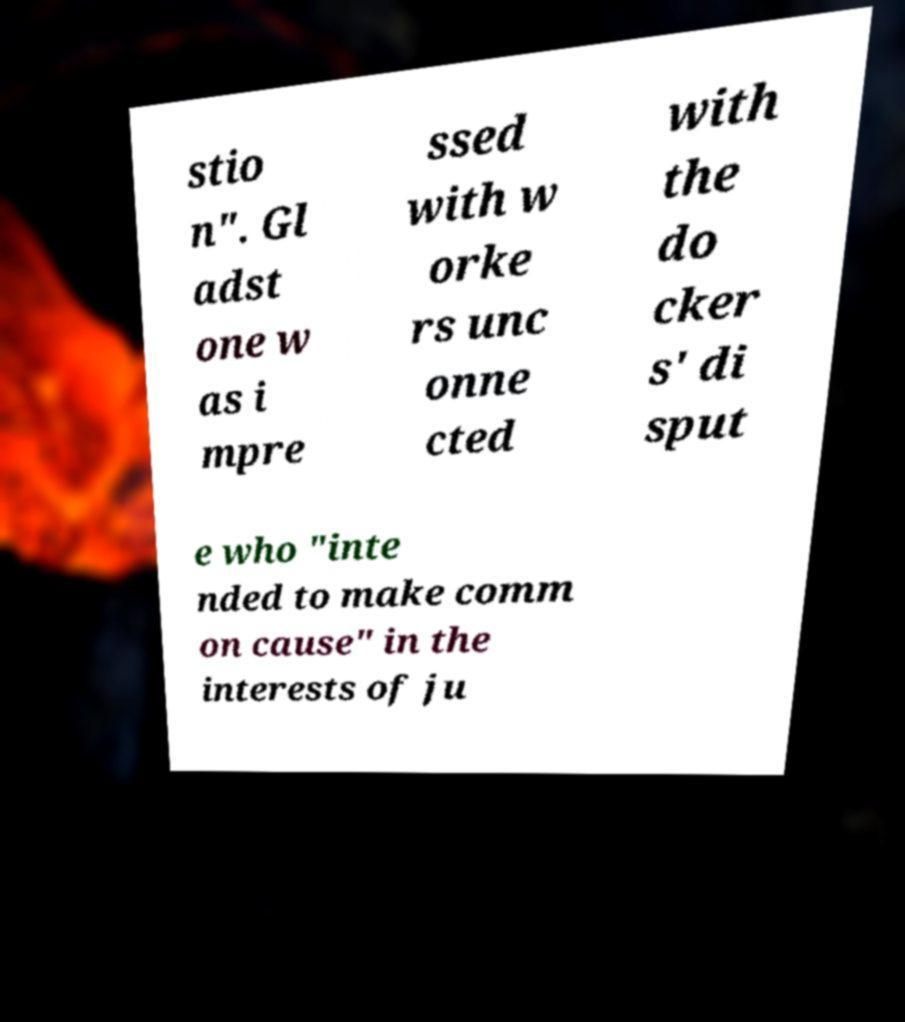Can you read and provide the text displayed in the image?This photo seems to have some interesting text. Can you extract and type it out for me? stio n". Gl adst one w as i mpre ssed with w orke rs unc onne cted with the do cker s' di sput e who "inte nded to make comm on cause" in the interests of ju 